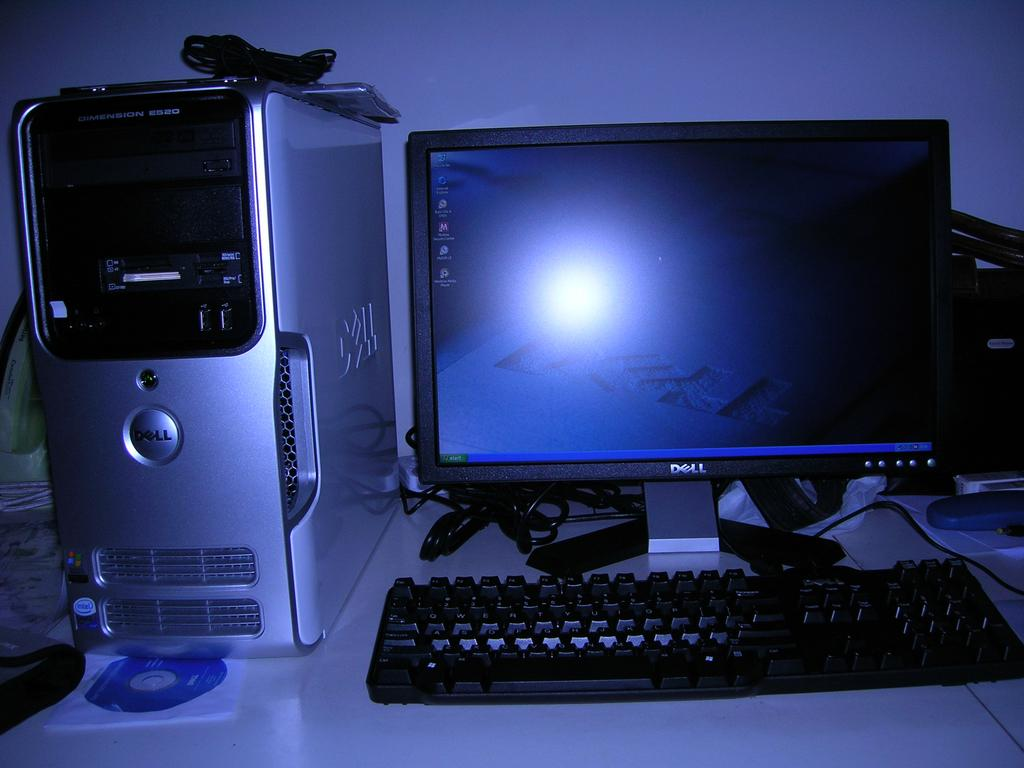<image>
Present a compact description of the photo's key features. A computer that says Dell on both the tower and the monitor is on a white desk. 